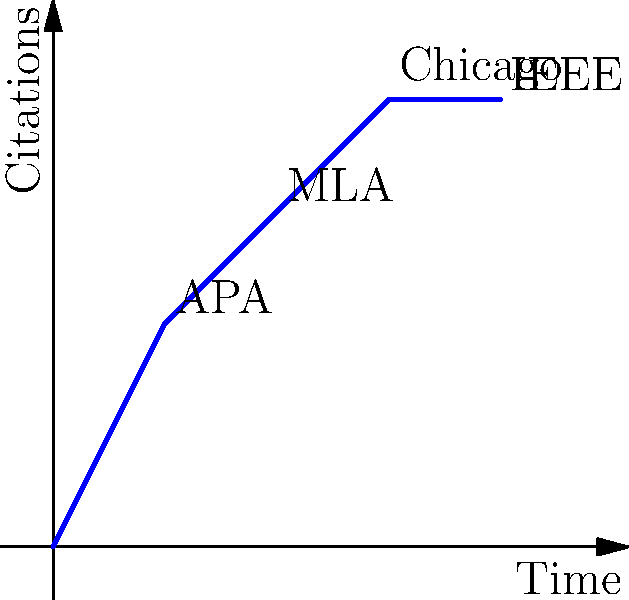In a LaTeX document, you need to generate a bibliography with different citation styles for various sections. The graph shows the time taken to implement different citation styles. Which citation style, according to the graph, takes the least additional time to implement after already implementing the APA style? To determine which citation style takes the least additional time to implement after APA, we need to analyze the graph step-by-step:

1. Identify the time taken for APA style:
   - APA is at point (1,2), meaning it takes 2 units of time.

2. Calculate the additional time for each style after APA:
   - MLA: At point (2,3), so 3 - 2 = 1 unit of additional time
   - Chicago: At point (3,4), so 4 - 2 = 2 units of additional time
   - IEEE: At point (4,4), so 4 - 2 = 2 units of additional time

3. Compare the additional time:
   - MLA: 1 unit
   - Chicago: 2 units
   - IEEE: 2 units

4. Identify the style with the least additional time:
   - MLA has the smallest additional time of 1 unit.

Therefore, MLA takes the least additional time to implement after already implementing the APA style.
Answer: MLA 